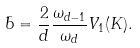<formula> <loc_0><loc_0><loc_500><loc_500>\bar { b } = \frac { 2 } { d } \frac { \omega _ { d - 1 } } { \omega _ { d } } V _ { 1 } ( K ) .</formula> 